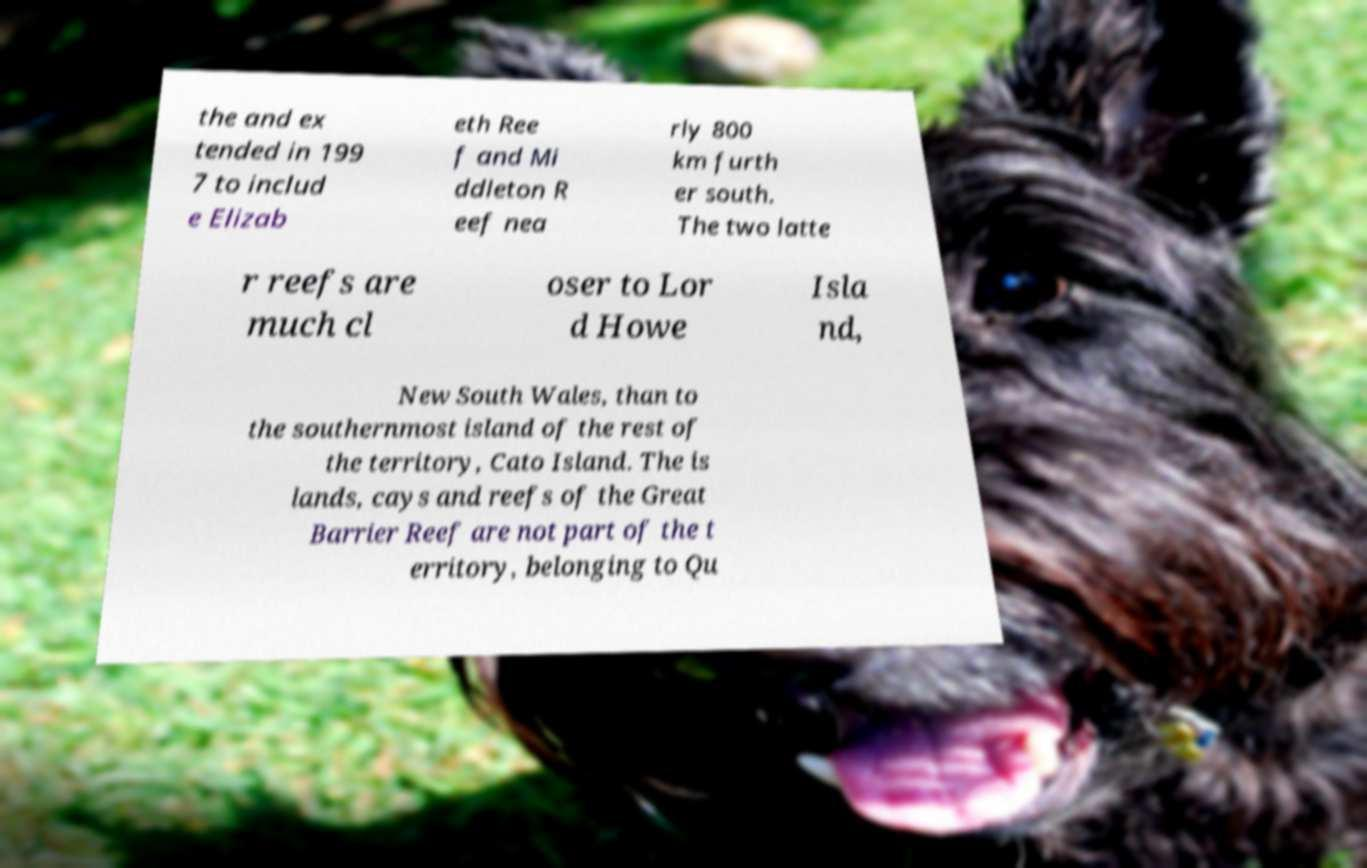Please identify and transcribe the text found in this image. the and ex tended in 199 7 to includ e Elizab eth Ree f and Mi ddleton R eef nea rly 800 km furth er south. The two latte r reefs are much cl oser to Lor d Howe Isla nd, New South Wales, than to the southernmost island of the rest of the territory, Cato Island. The is lands, cays and reefs of the Great Barrier Reef are not part of the t erritory, belonging to Qu 